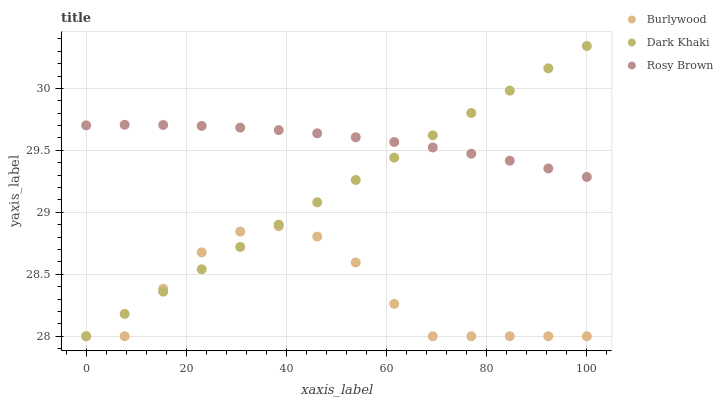Does Burlywood have the minimum area under the curve?
Answer yes or no. Yes. Does Rosy Brown have the maximum area under the curve?
Answer yes or no. Yes. Does Dark Khaki have the minimum area under the curve?
Answer yes or no. No. Does Dark Khaki have the maximum area under the curve?
Answer yes or no. No. Is Dark Khaki the smoothest?
Answer yes or no. Yes. Is Burlywood the roughest?
Answer yes or no. Yes. Is Rosy Brown the smoothest?
Answer yes or no. No. Is Rosy Brown the roughest?
Answer yes or no. No. Does Burlywood have the lowest value?
Answer yes or no. Yes. Does Rosy Brown have the lowest value?
Answer yes or no. No. Does Dark Khaki have the highest value?
Answer yes or no. Yes. Does Rosy Brown have the highest value?
Answer yes or no. No. Is Burlywood less than Rosy Brown?
Answer yes or no. Yes. Is Rosy Brown greater than Burlywood?
Answer yes or no. Yes. Does Rosy Brown intersect Dark Khaki?
Answer yes or no. Yes. Is Rosy Brown less than Dark Khaki?
Answer yes or no. No. Is Rosy Brown greater than Dark Khaki?
Answer yes or no. No. Does Burlywood intersect Rosy Brown?
Answer yes or no. No. 